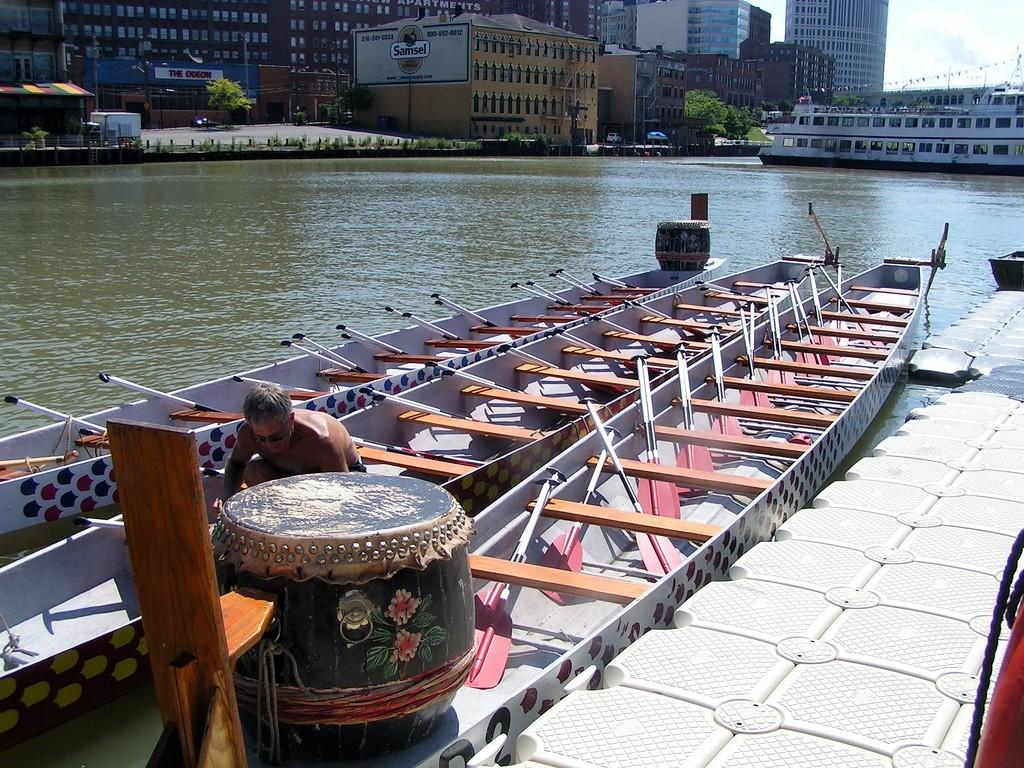What type of structures can be seen in the image? There are buildings in the image. What natural elements are present in the image? There are trees and water visible in the image. What man-made objects can be seen in the water? There are boats in the image. Can you see any fish swimming in the water in the image? There are no fish visible in the image; it only shows boats in the water. What type of protest is taking place in the image? There is no protest present in the image; it features buildings, trees, water, and boats. 